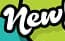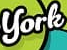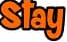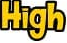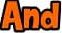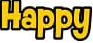What words are shown in these images in order, separated by a semicolon? New; York; Stay; High; And; Happy 